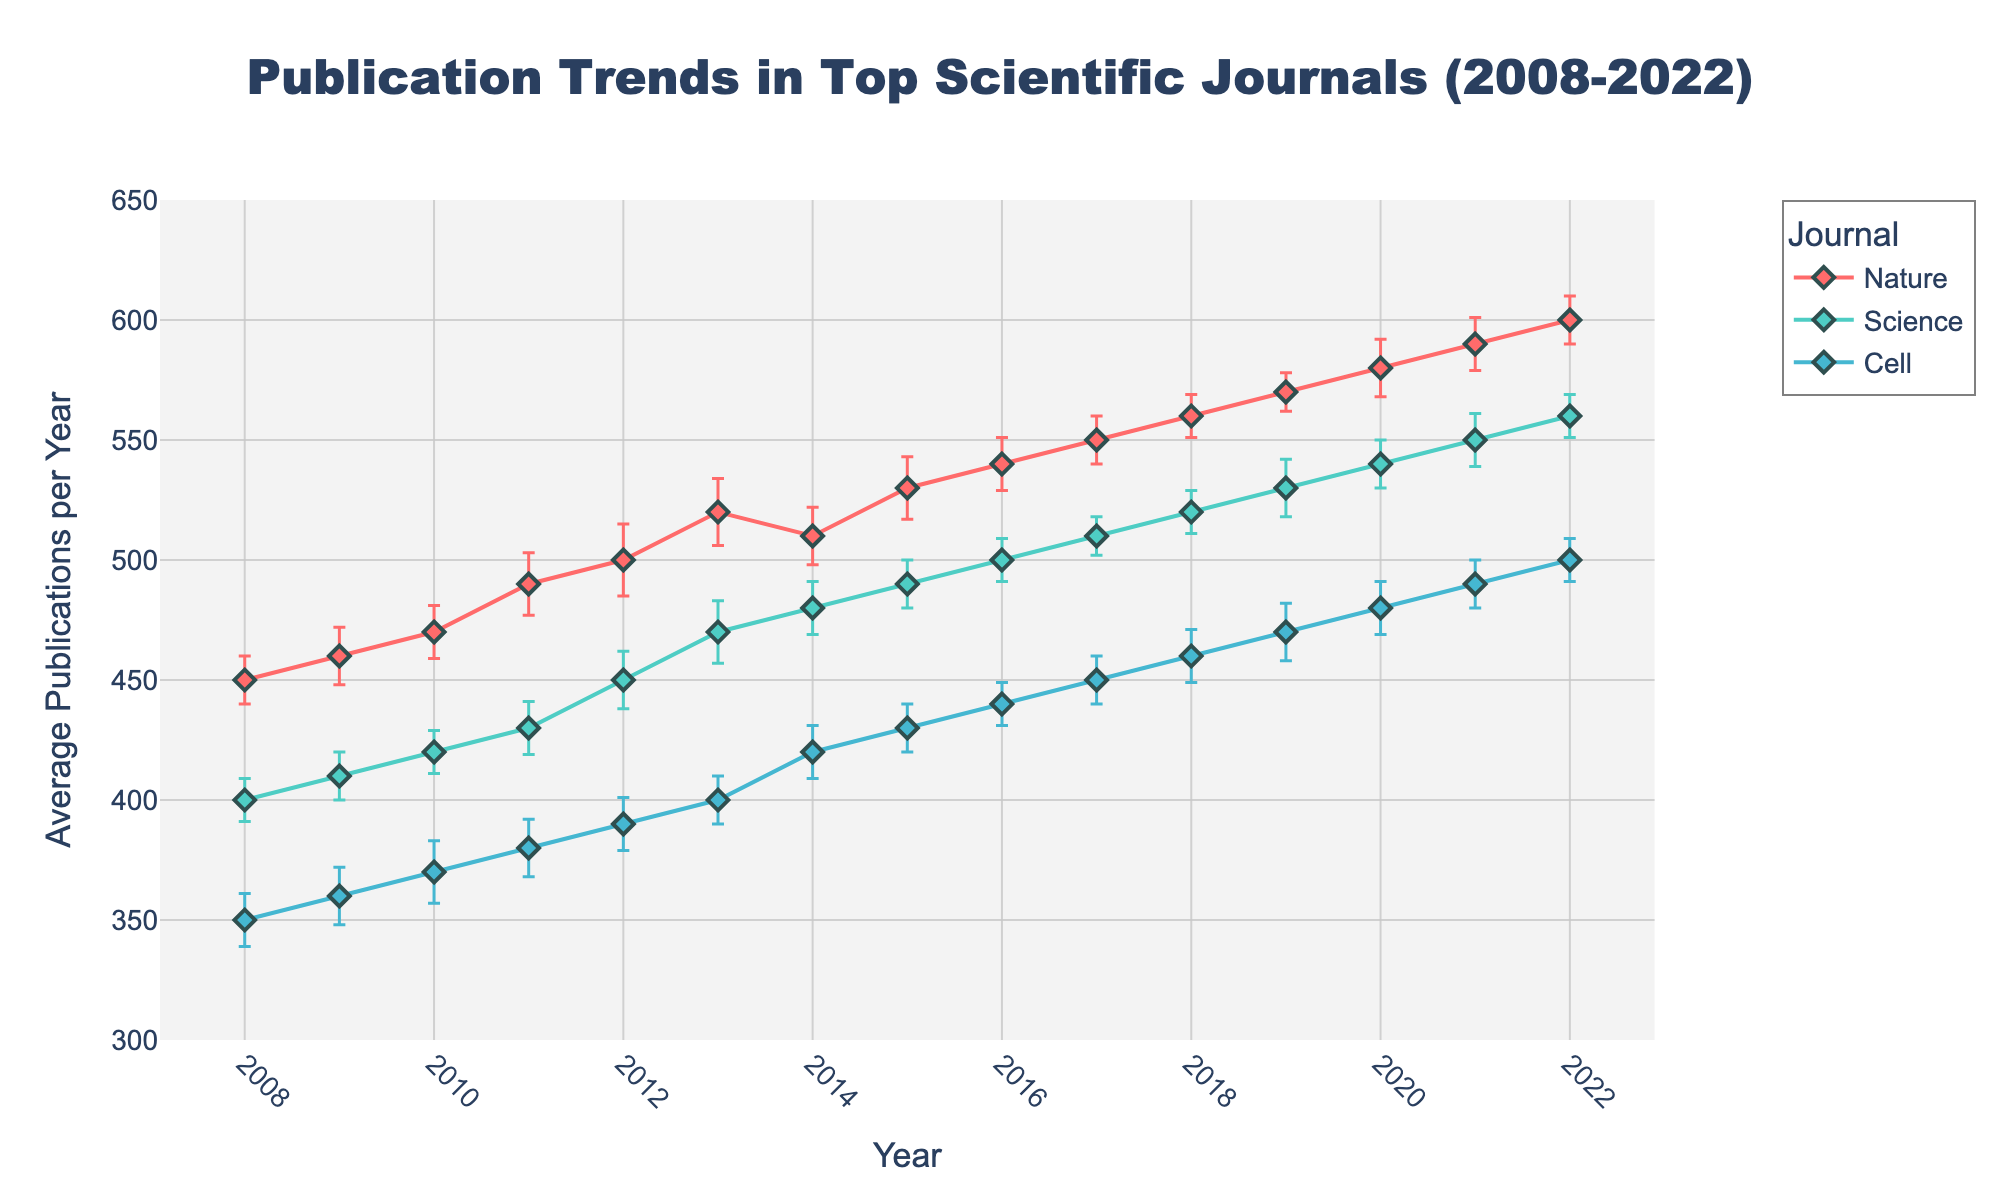What is the title of the figure? The title of the figure is displayed at the top. It reads "Publication Trends in Top Scientific Journals (2008-2022)."
Answer: Publication Trends in Top Scientific Journals (2008-2022) How many journals are represented in the plot? By looking at the different colors and the legend, we can see that there are three journals represented: Nature, Science, and Cell.
Answer: Three Which journal had the highest average publications in 2022? To determine this, we look at the data points for 2022 and compare the values for Nature, Science, and Cell. Nature has the highest value at 600 publications.
Answer: Nature By how much did the average publications in Science increase from 2008 to 2022? The average publications in Science in 2008 were 400, and in 2022, they were 560. The increase is calculated as 560 - 400.
Answer: 160 Compare the trend of average publications for Cell and Nature between 2008 and 2022. Which journal shows a steeper increase? To compare trends, we look at the slope of the lines. Nature's publications increase from 450 to 600 (an increase of 150), and Cell's publications increase from 350 to 500 (an increase of 150). Both journals show the same increase, so there is no steeper increase for either.
Answer: Both have the same increase What is the average publication rate of Cell in the decade of 2010-2019? The given data points for Cell between 2010-2019 are summed up (370+380+390+400+420+430+440+450+460+470) and then divided by the number of years (10).
Answer: 421 What is the error range for Nature's average publications in 2010? The average publication for Nature in 2010 is 470, and the standard error is 11. The error range is from 470-11 to 470+11.
Answer: 459 to 481 Which year shows the smallest standard error for Science, and what is its value? By scanning the standard errors for Science, we find that the smallest error is 8 in the year 2017.
Answer: 2017, 8 During what period did Nature experience the most significant increase in average publications? We look at the slopes during various intervals for Nature. The biggest change from consecutive years is between 2019 (570) and 2020 (580).
Answer: 2019-2020 